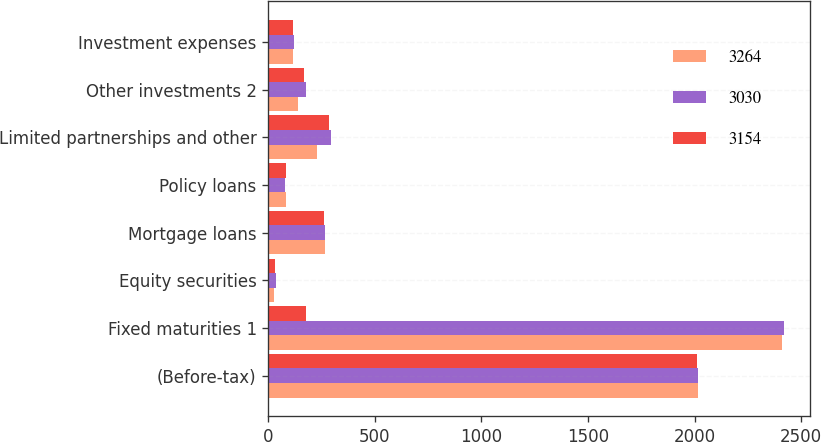Convert chart. <chart><loc_0><loc_0><loc_500><loc_500><stacked_bar_chart><ecel><fcel>(Before-tax)<fcel>Fixed maturities 1<fcel>Equity securities<fcel>Mortgage loans<fcel>Policy loans<fcel>Limited partnerships and other<fcel>Other investments 2<fcel>Investment expenses<nl><fcel>3264<fcel>2015<fcel>2409<fcel>25<fcel>267<fcel>82<fcel>227<fcel>138<fcel>118<nl><fcel>3030<fcel>2014<fcel>2420<fcel>38<fcel>265<fcel>80<fcel>294<fcel>179<fcel>122<nl><fcel>3154<fcel>2013<fcel>179<fcel>30<fcel>260<fcel>83<fcel>287<fcel>167<fcel>115<nl></chart> 